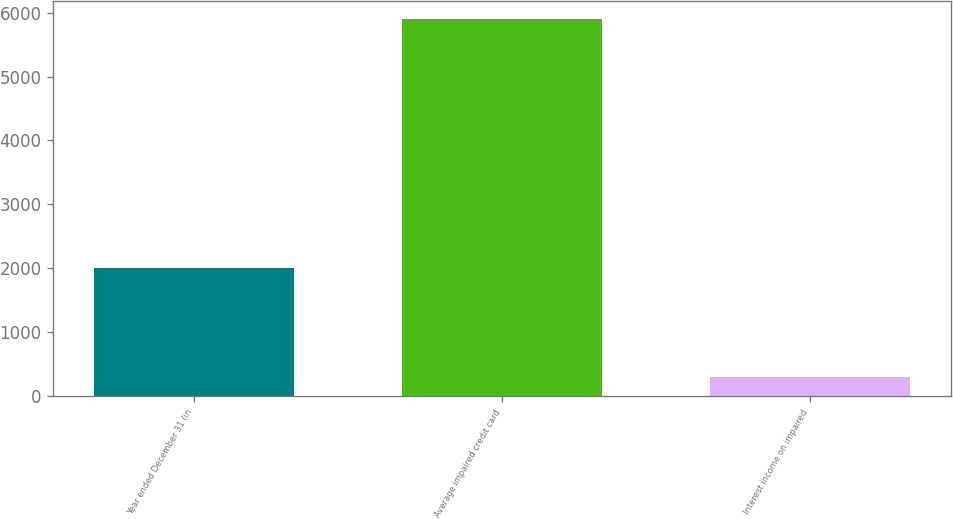<chart> <loc_0><loc_0><loc_500><loc_500><bar_chart><fcel>Year ended December 31 (in<fcel>Average impaired credit card<fcel>Interest income on impaired<nl><fcel>2012<fcel>5893<fcel>308<nl></chart> 